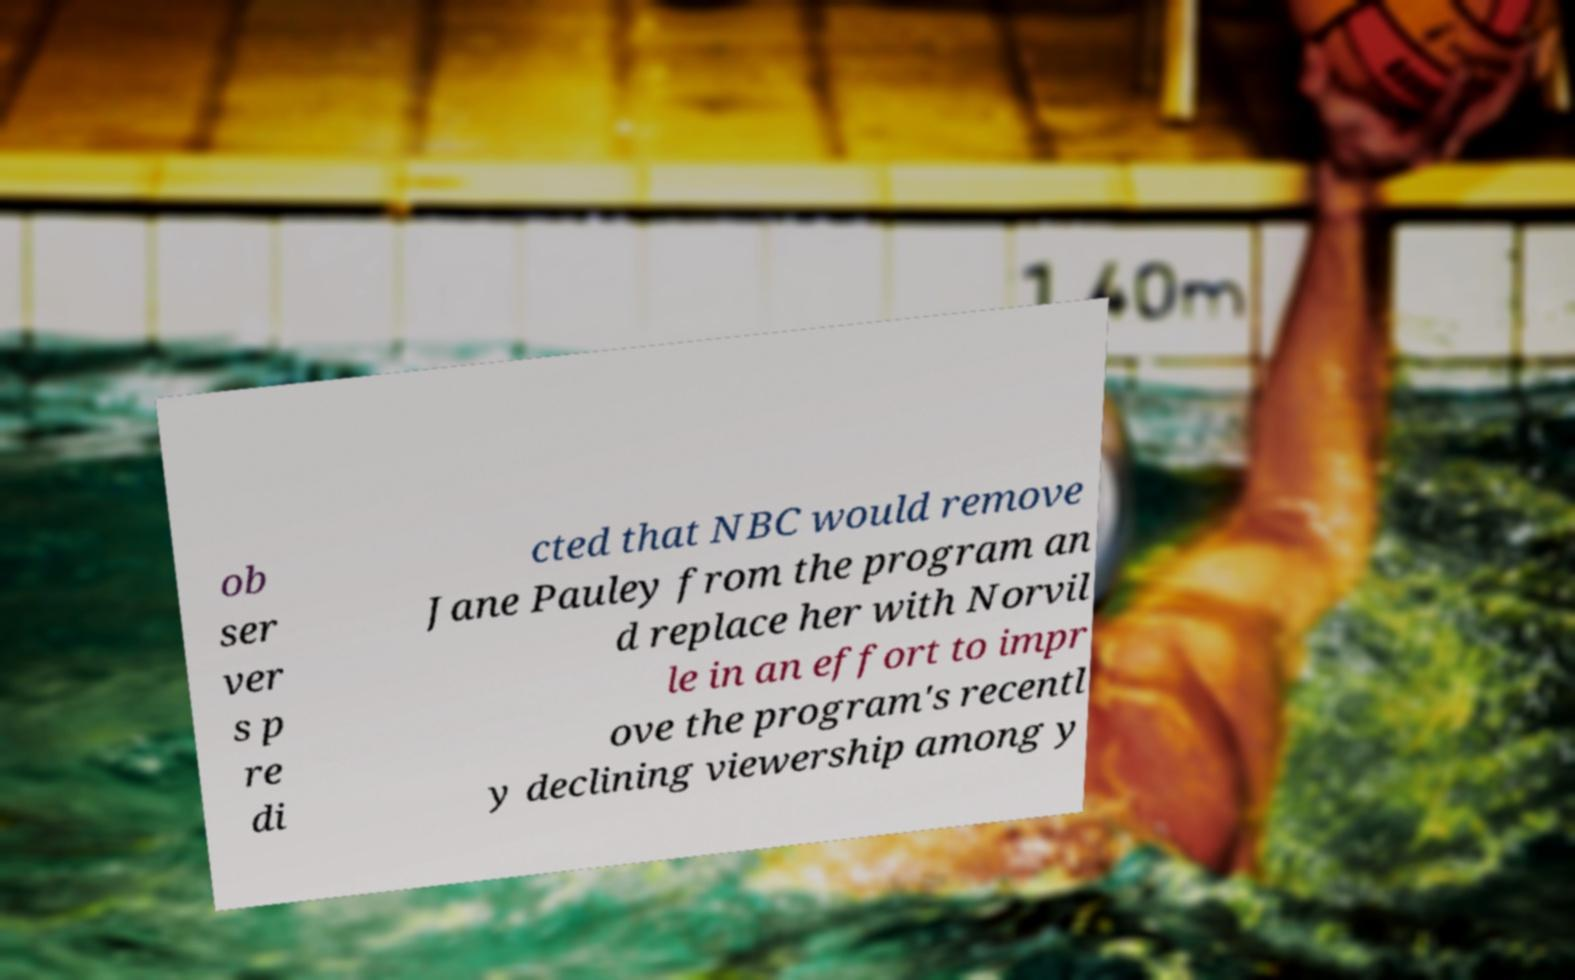Could you extract and type out the text from this image? ob ser ver s p re di cted that NBC would remove Jane Pauley from the program an d replace her with Norvil le in an effort to impr ove the program's recentl y declining viewership among y 